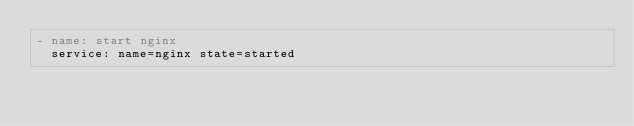<code> <loc_0><loc_0><loc_500><loc_500><_YAML_>- name: start nginx
  service: name=nginx state=started
</code> 